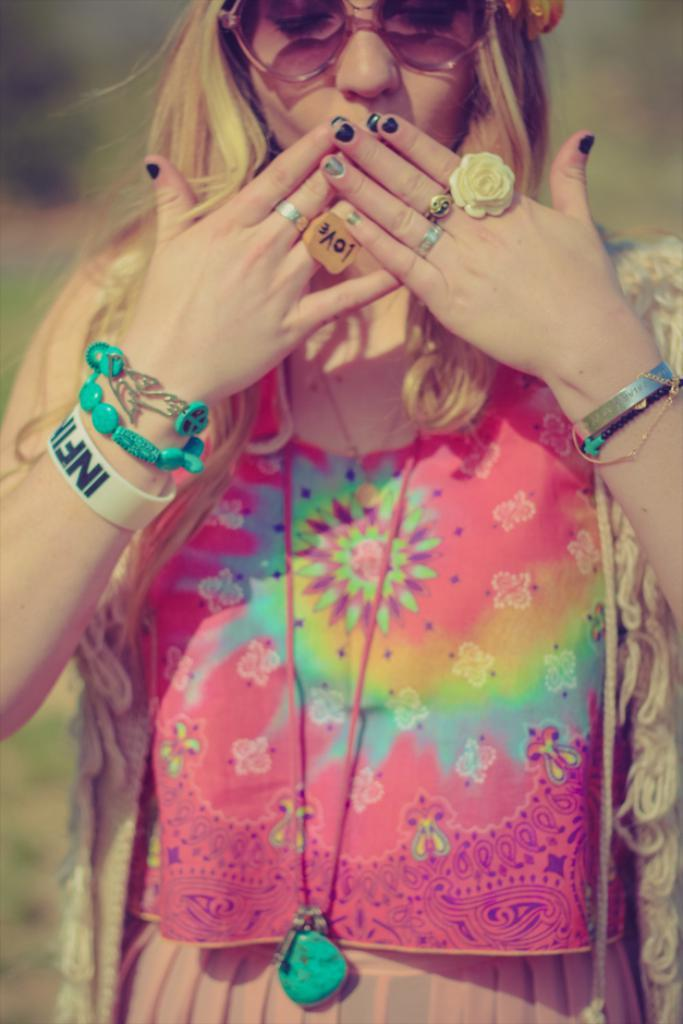Who is the main subject in the image? There is a woman in the image. What accessory is the woman wearing? The woman is wearing glasses. What type of jewelry is the woman wearing? The woman is wearing ornaments. What type of clothing is the woman wearing? The woman is wearing a dress. Can you describe the background of the image? The background of the image is blurred. What type of breakfast is the woman eating in the image? There is no breakfast present in the image; it only features a woman wearing glasses, ornaments, and a dress, with a blurred background. 